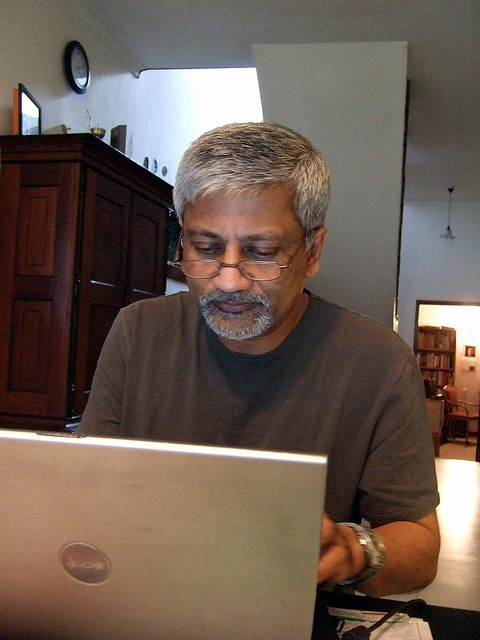Describe the objects in this image and their specific colors. I can see people in gray, maroon, and black tones, laptop in gray, tan, and brown tones, clock in gray, black, and lavender tones, clock in gray, olive, and tan tones, and book in gray, maroon, and brown tones in this image. 